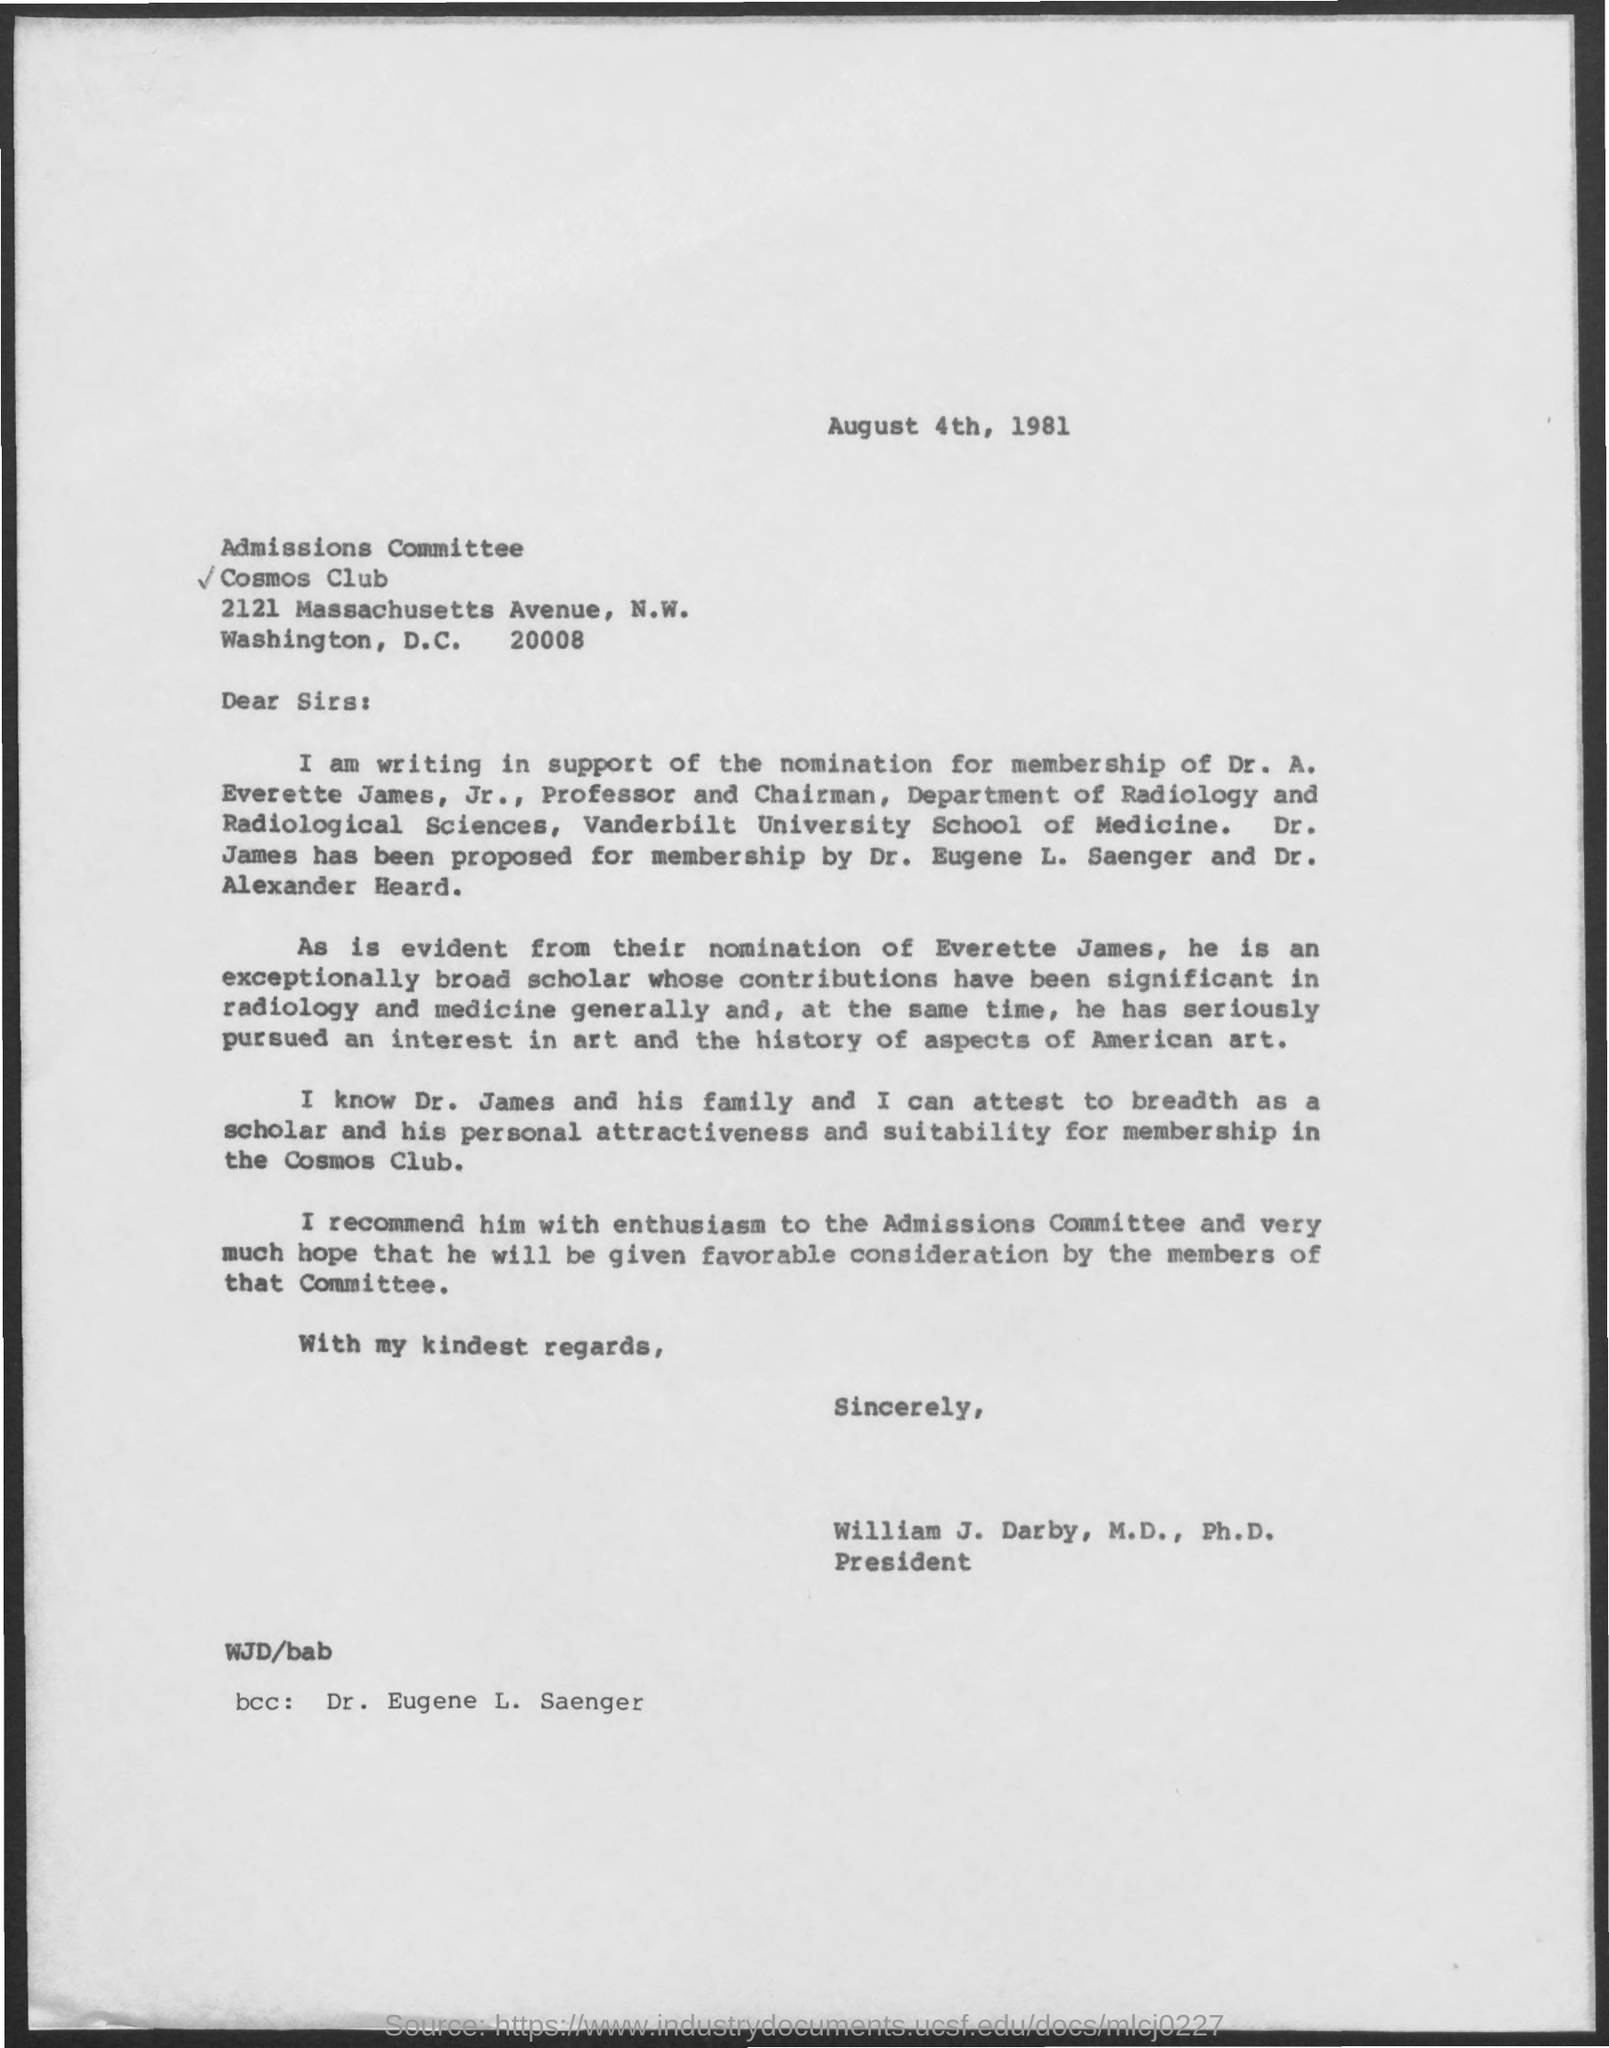Point out several critical features in this image. The Memorandum was dated August 4, 1981. The person referred to as "bcc" is Dr. Eugene L. Saenger. 